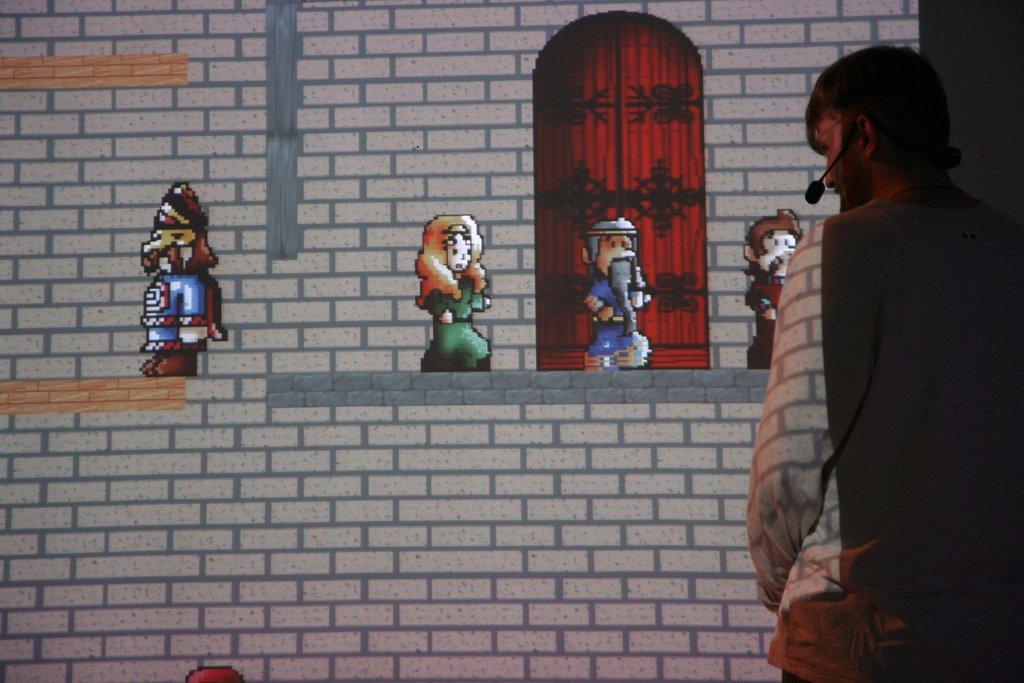Please provide a concise description of this image. In this image we can see a person wore a mike. In the background we can see wall and pictures. 